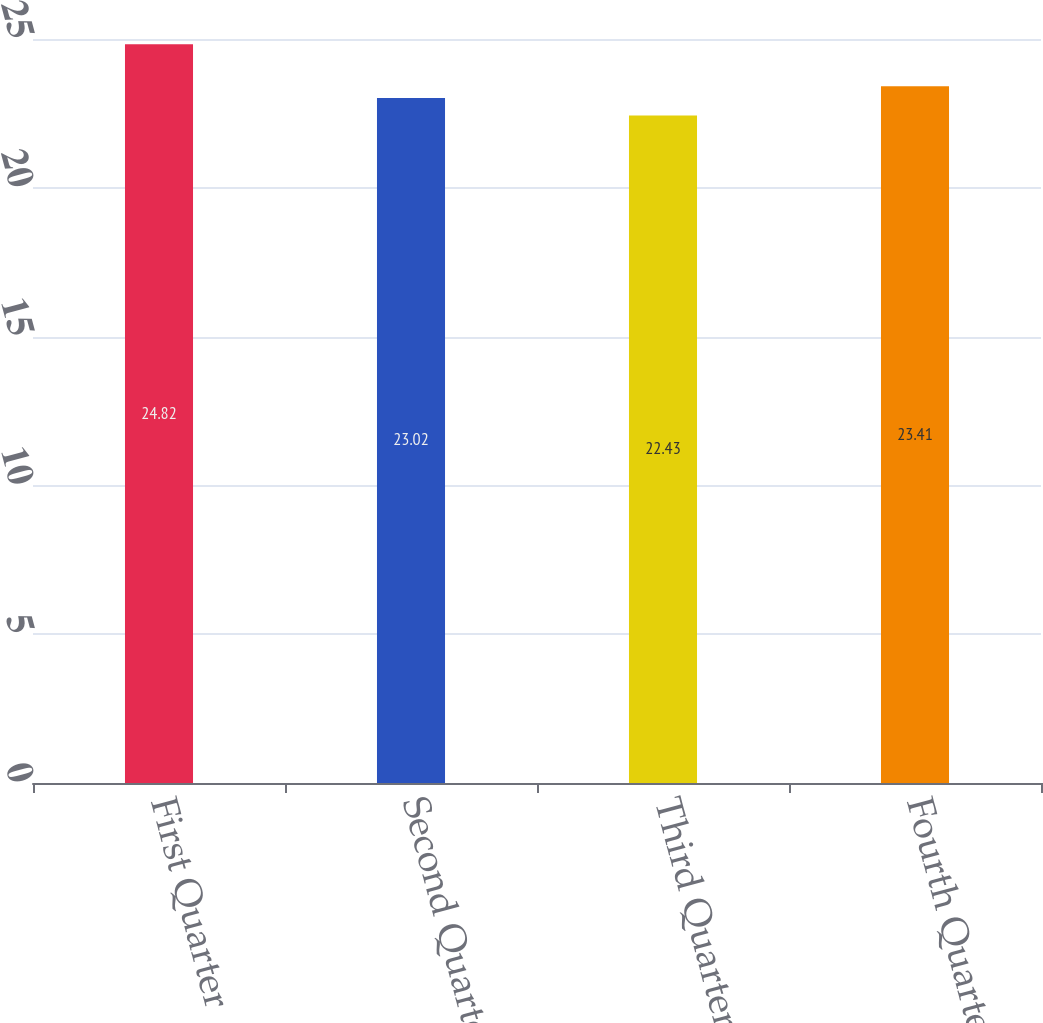Convert chart to OTSL. <chart><loc_0><loc_0><loc_500><loc_500><bar_chart><fcel>First Quarter<fcel>Second Quarter<fcel>Third Quarter<fcel>Fourth Quarter<nl><fcel>24.82<fcel>23.02<fcel>22.43<fcel>23.41<nl></chart> 